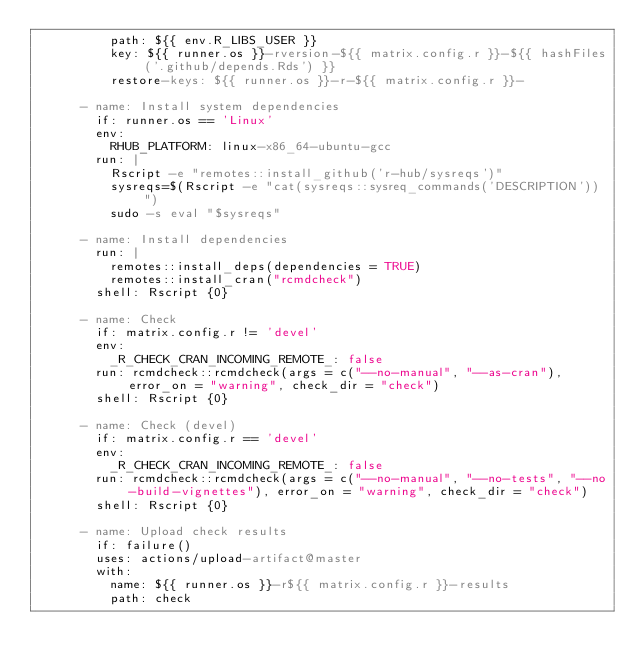<code> <loc_0><loc_0><loc_500><loc_500><_YAML_>          path: ${{ env.R_LIBS_USER }}
          key: ${{ runner.os }}-rversion-${{ matrix.config.r }}-${{ hashFiles('.github/depends.Rds') }}
          restore-keys: ${{ runner.os }}-r-${{ matrix.config.r }}-

      - name: Install system dependencies
        if: runner.os == 'Linux'
        env:
          RHUB_PLATFORM: linux-x86_64-ubuntu-gcc
        run: |
          Rscript -e "remotes::install_github('r-hub/sysreqs')"
          sysreqs=$(Rscript -e "cat(sysreqs::sysreq_commands('DESCRIPTION'))")
          sudo -s eval "$sysreqs"

      - name: Install dependencies
        run: |
          remotes::install_deps(dependencies = TRUE)
          remotes::install_cran("rcmdcheck")
        shell: Rscript {0}

      - name: Check
        if: matrix.config.r != 'devel'
        env:
          _R_CHECK_CRAN_INCOMING_REMOTE_: false
        run: rcmdcheck::rcmdcheck(args = c("--no-manual", "--as-cran"), error_on = "warning", check_dir = "check")
        shell: Rscript {0}

      - name: Check (devel)
        if: matrix.config.r == 'devel'
        env:
          _R_CHECK_CRAN_INCOMING_REMOTE_: false
        run: rcmdcheck::rcmdcheck(args = c("--no-manual", "--no-tests", "--no-build-vignettes"), error_on = "warning", check_dir = "check")
        shell: Rscript {0}

      - name: Upload check results
        if: failure()
        uses: actions/upload-artifact@master
        with:
          name: ${{ runner.os }}-r${{ matrix.config.r }}-results
          path: check
</code> 